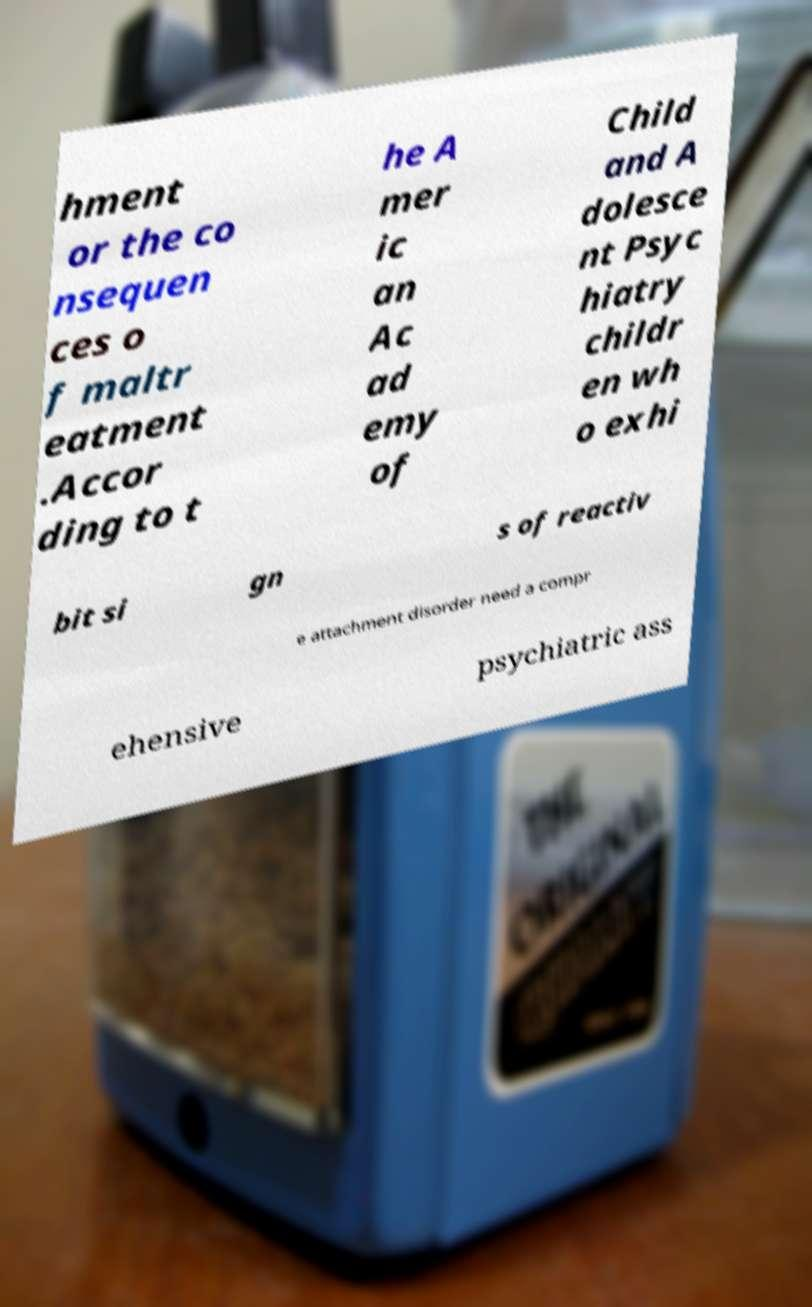Could you assist in decoding the text presented in this image and type it out clearly? hment or the co nsequen ces o f maltr eatment .Accor ding to t he A mer ic an Ac ad emy of Child and A dolesce nt Psyc hiatry childr en wh o exhi bit si gn s of reactiv e attachment disorder need a compr ehensive psychiatric ass 